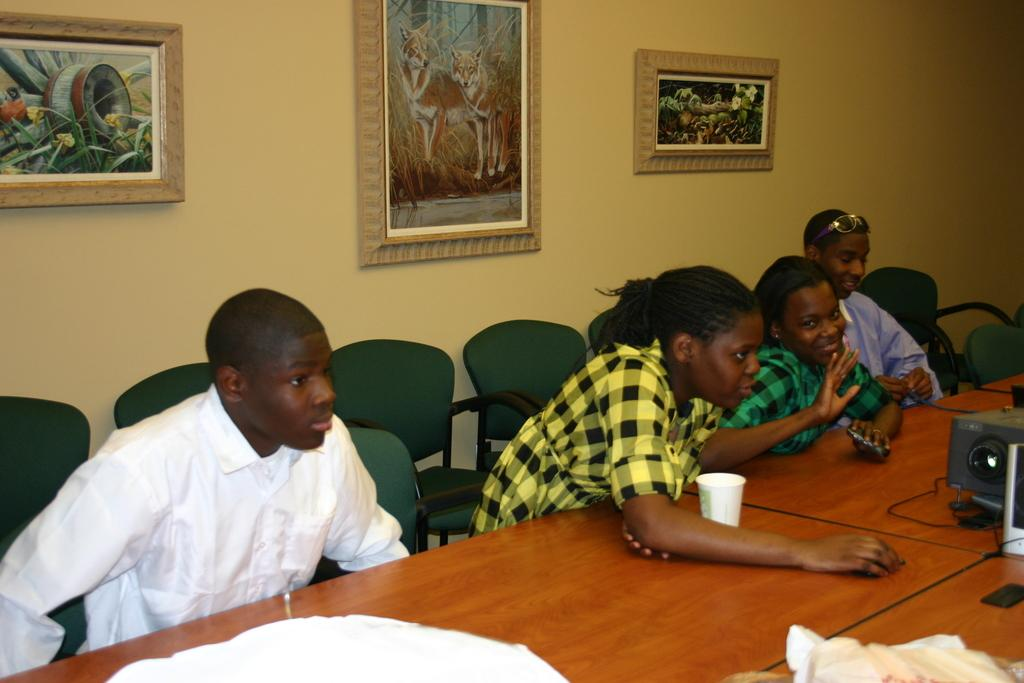What are the people in the image doing? The people in the image are sitting on chairs near a table. What is on the table in the image? There is a glass and a projector on the table. What can be seen in the background of the image? There is a wall and a photo frame in the background. What type of machine is being used to wash dishes in the image? There is no machine or sink present in the image, so it is not possible to determine if any dishwashing is taking place. 